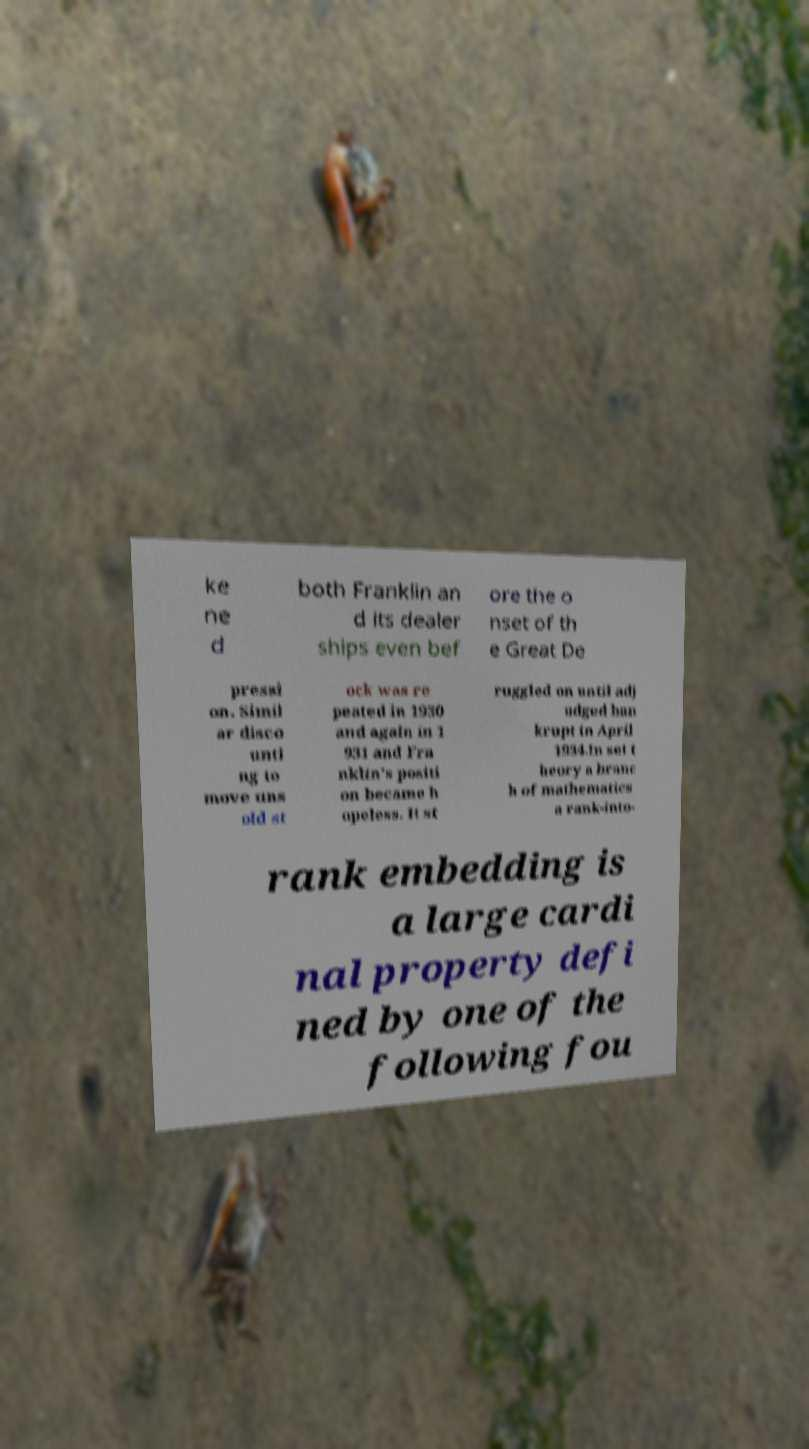Can you accurately transcribe the text from the provided image for me? ke ne d both Franklin an d its dealer ships even bef ore the o nset of th e Great De pressi on. Simil ar disco unti ng to move uns old st ock was re peated in 1930 and again in 1 931 and Fra nklin's positi on became h opeless. It st ruggled on until adj udged ban krupt in April 1934.In set t heory a branc h of mathematics a rank-into- rank embedding is a large cardi nal property defi ned by one of the following fou 